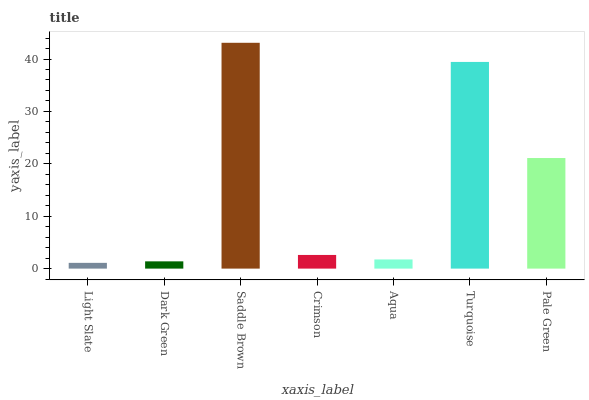Is Light Slate the minimum?
Answer yes or no. Yes. Is Saddle Brown the maximum?
Answer yes or no. Yes. Is Dark Green the minimum?
Answer yes or no. No. Is Dark Green the maximum?
Answer yes or no. No. Is Dark Green greater than Light Slate?
Answer yes or no. Yes. Is Light Slate less than Dark Green?
Answer yes or no. Yes. Is Light Slate greater than Dark Green?
Answer yes or no. No. Is Dark Green less than Light Slate?
Answer yes or no. No. Is Crimson the high median?
Answer yes or no. Yes. Is Crimson the low median?
Answer yes or no. Yes. Is Pale Green the high median?
Answer yes or no. No. Is Light Slate the low median?
Answer yes or no. No. 